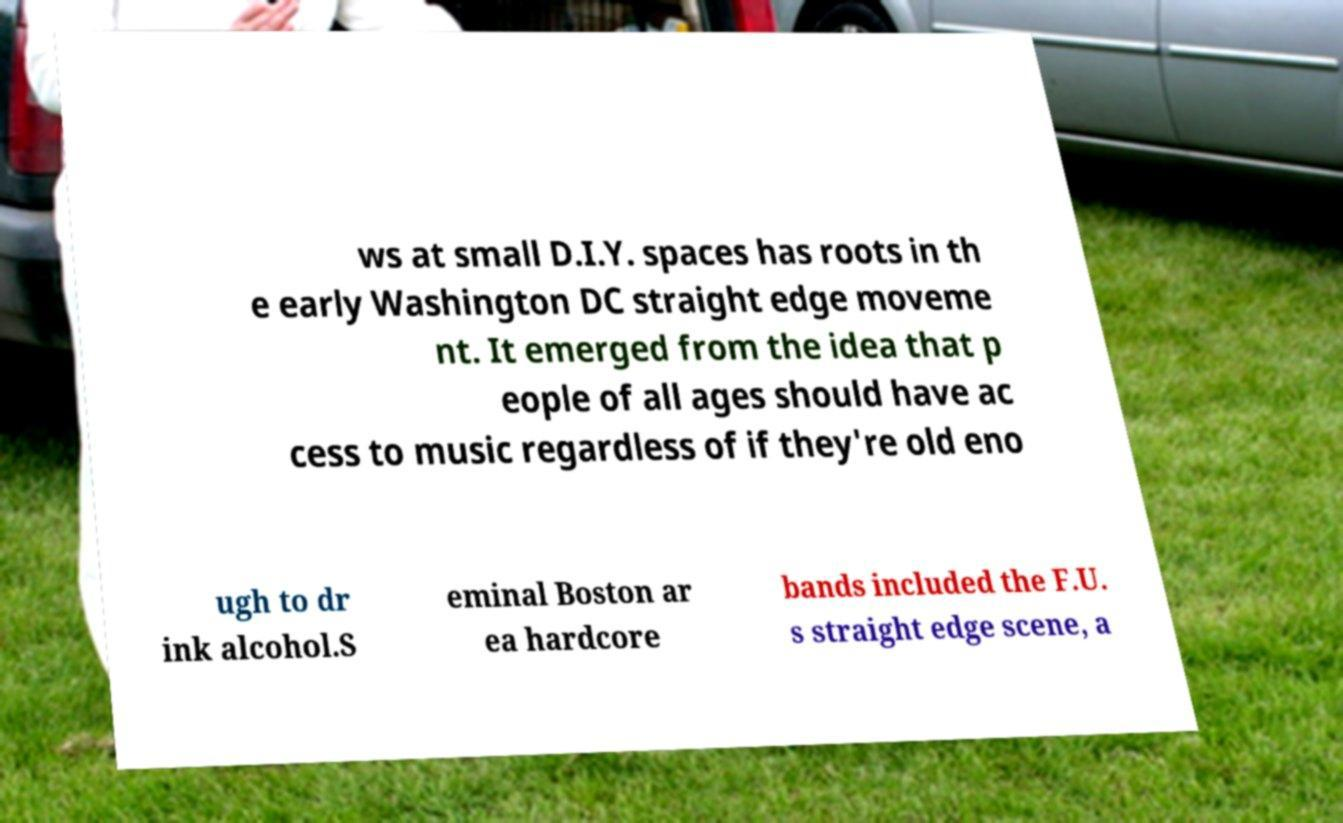What messages or text are displayed in this image? I need them in a readable, typed format. ws at small D.I.Y. spaces has roots in th e early Washington DC straight edge moveme nt. It emerged from the idea that p eople of all ages should have ac cess to music regardless of if they're old eno ugh to dr ink alcohol.S eminal Boston ar ea hardcore bands included the F.U. s straight edge scene, a 